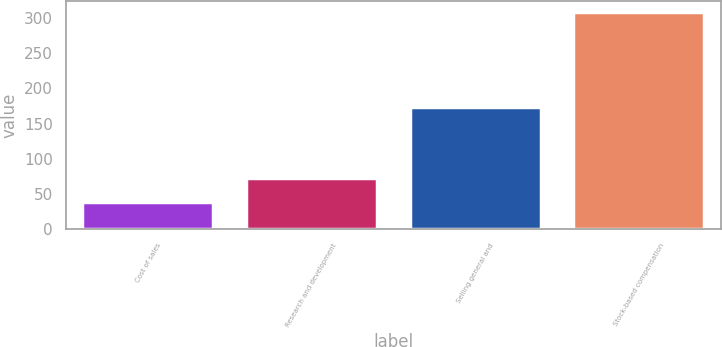Convert chart. <chart><loc_0><loc_0><loc_500><loc_500><bar_chart><fcel>Cost of sales<fcel>Research and development<fcel>Selling general and<fcel>Stock-based compensation<nl><fcel>39<fcel>73<fcel>174<fcel>309<nl></chart> 